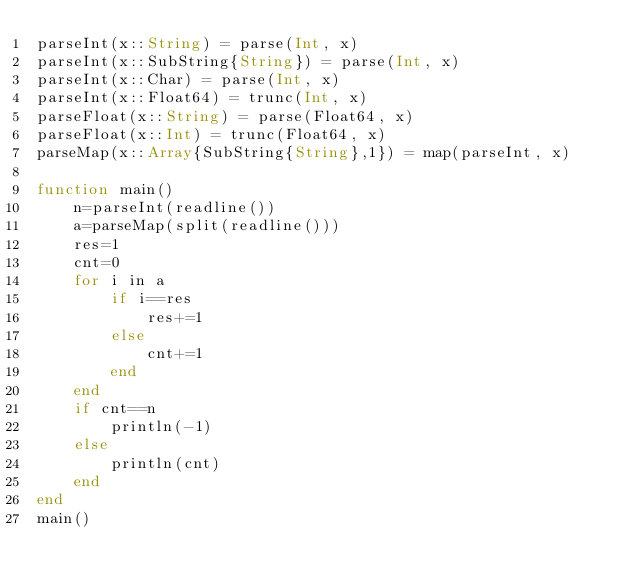Convert code to text. <code><loc_0><loc_0><loc_500><loc_500><_Julia_>parseInt(x::String) = parse(Int, x)
parseInt(x::SubString{String}) = parse(Int, x)
parseInt(x::Char) = parse(Int, x)
parseInt(x::Float64) = trunc(Int, x)
parseFloat(x::String) = parse(Float64, x)
parseFloat(x::Int) = trunc(Float64, x)
parseMap(x::Array{SubString{String},1}) = map(parseInt, x)

function main()
    n=parseInt(readline())
    a=parseMap(split(readline()))
    res=1
    cnt=0
    for i in a
        if i==res
            res+=1
        else
            cnt+=1
        end
    end
    if cnt==n
        println(-1)
    else
        println(cnt)
    end
end
main()</code> 